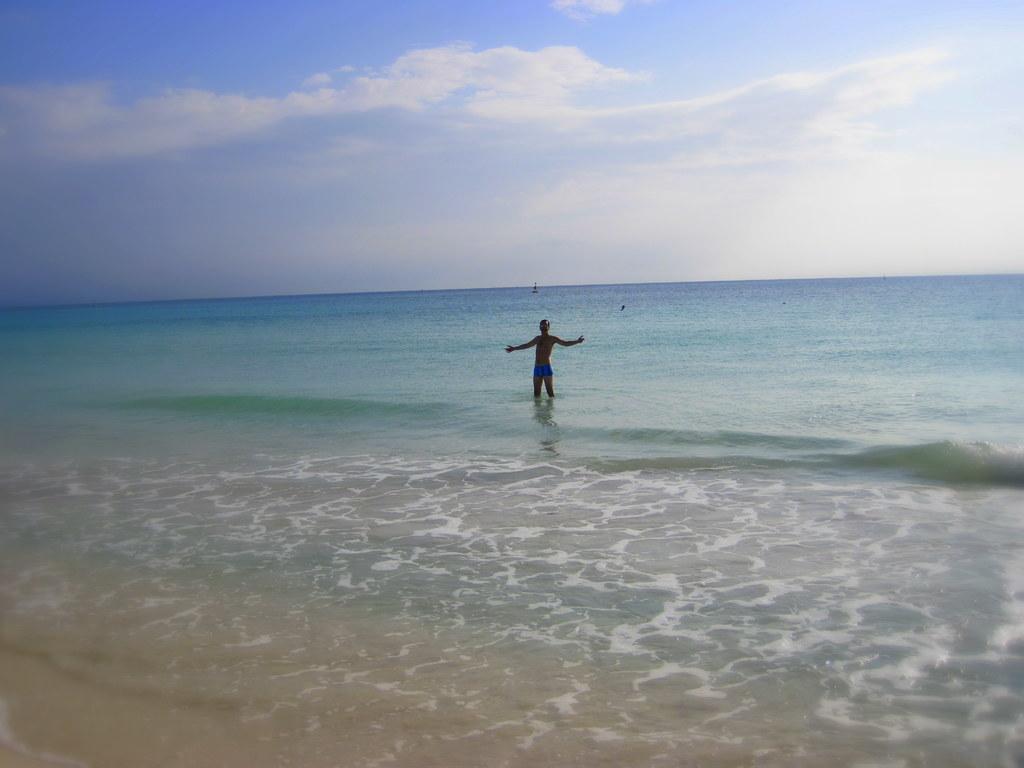Can you describe this image briefly? This image is clicked in a beach. There is water in the middle. In that there is one person standing. There is sky at the top. 